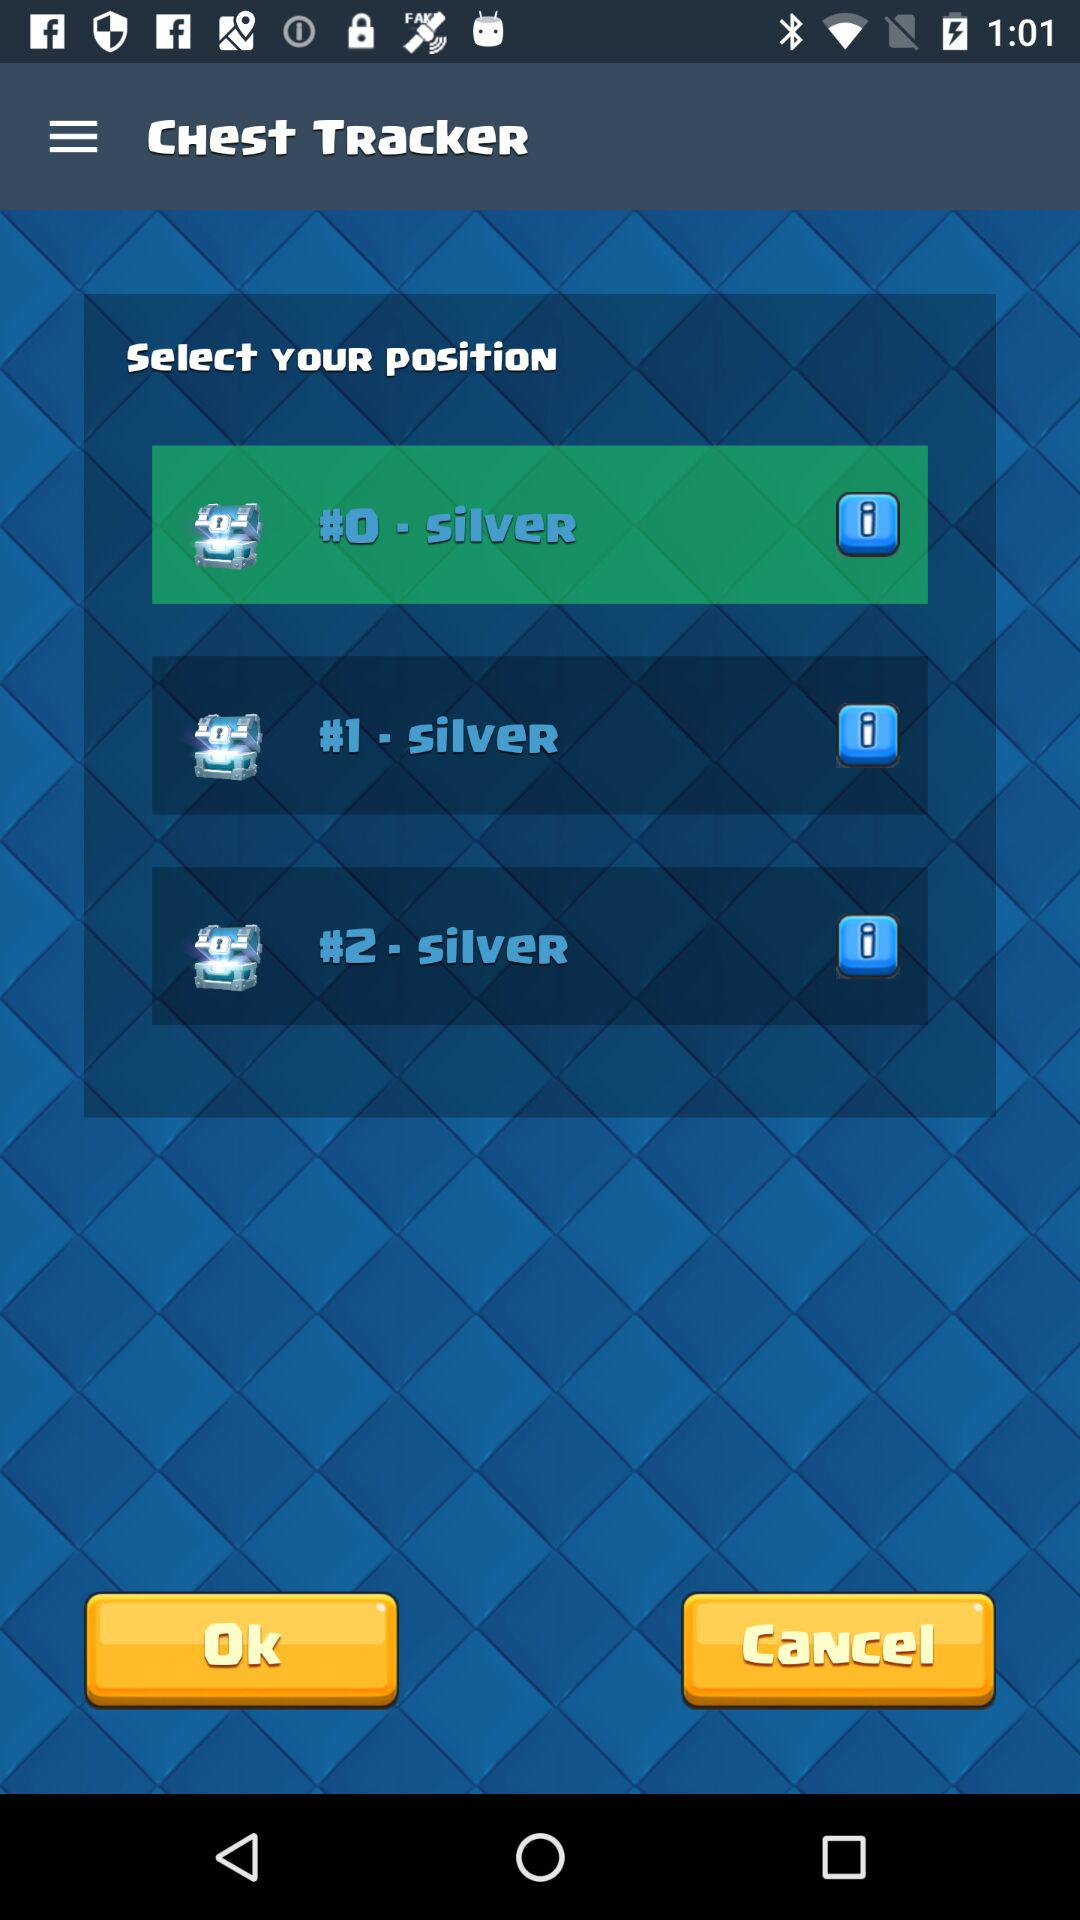How many chests are there with a silver chest?
Answer the question using a single word or phrase. 3 